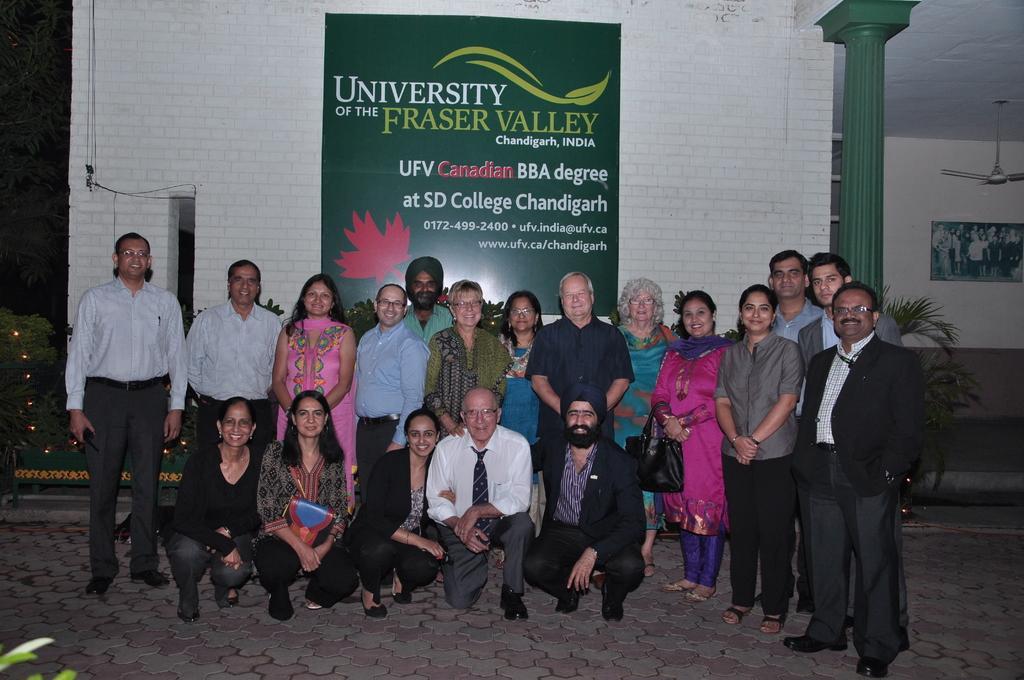How would you summarize this image in a sentence or two? In this image I can see a group of people standing and wearing different color dresses. Back I can see a building,green board,pillar,fan and frame is attached to the wall. 